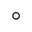<formula> <loc_0><loc_0><loc_500><loc_500>^ { \circ }</formula> 